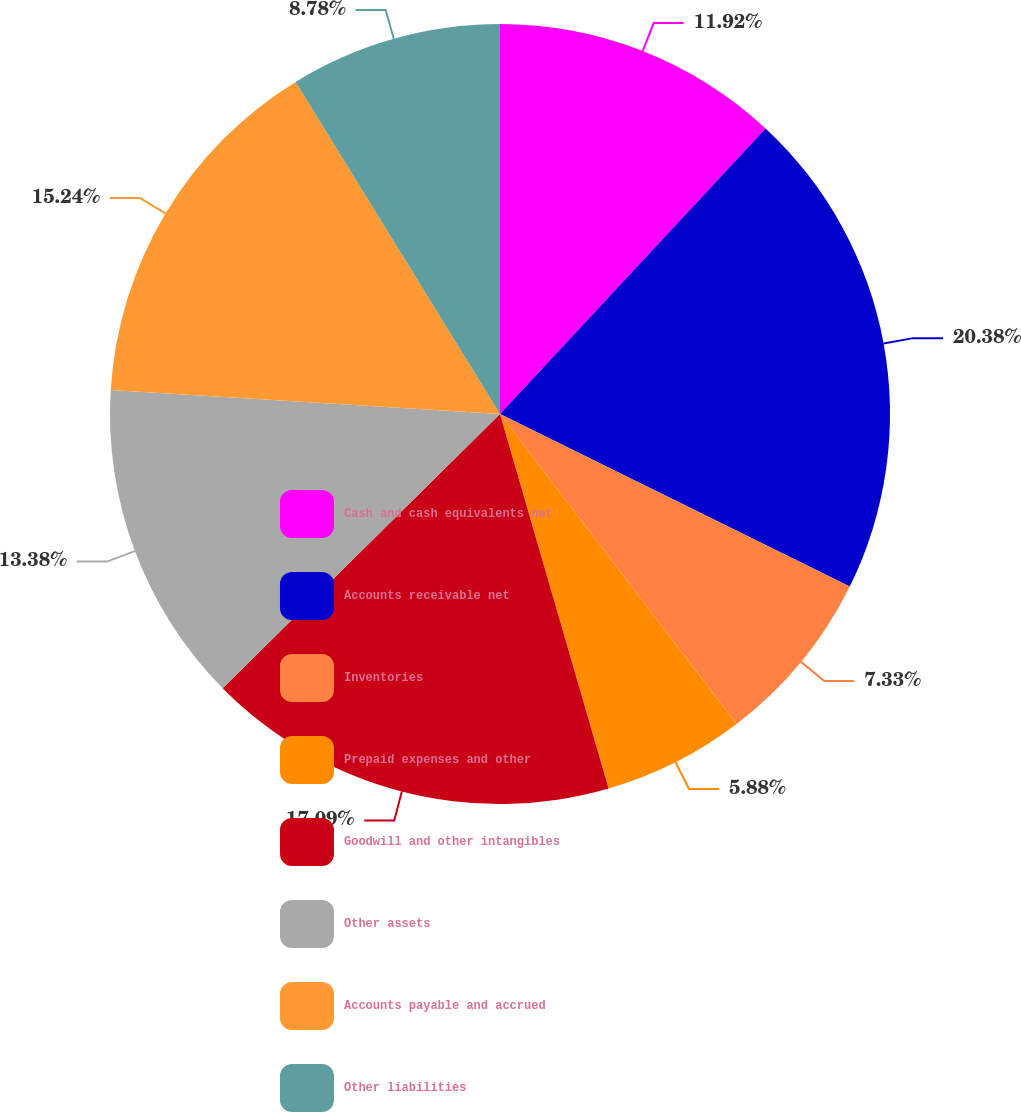Convert chart to OTSL. <chart><loc_0><loc_0><loc_500><loc_500><pie_chart><fcel>Cash and cash equivalents net<fcel>Accounts receivable net<fcel>Inventories<fcel>Prepaid expenses and other<fcel>Goodwill and other intangibles<fcel>Other assets<fcel>Accounts payable and accrued<fcel>Other liabilities<nl><fcel>11.92%<fcel>20.37%<fcel>7.33%<fcel>5.88%<fcel>17.08%<fcel>13.38%<fcel>15.24%<fcel>8.78%<nl></chart> 